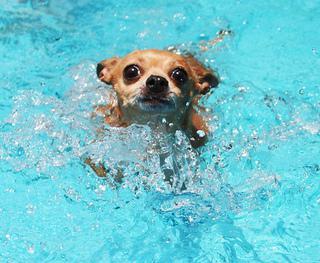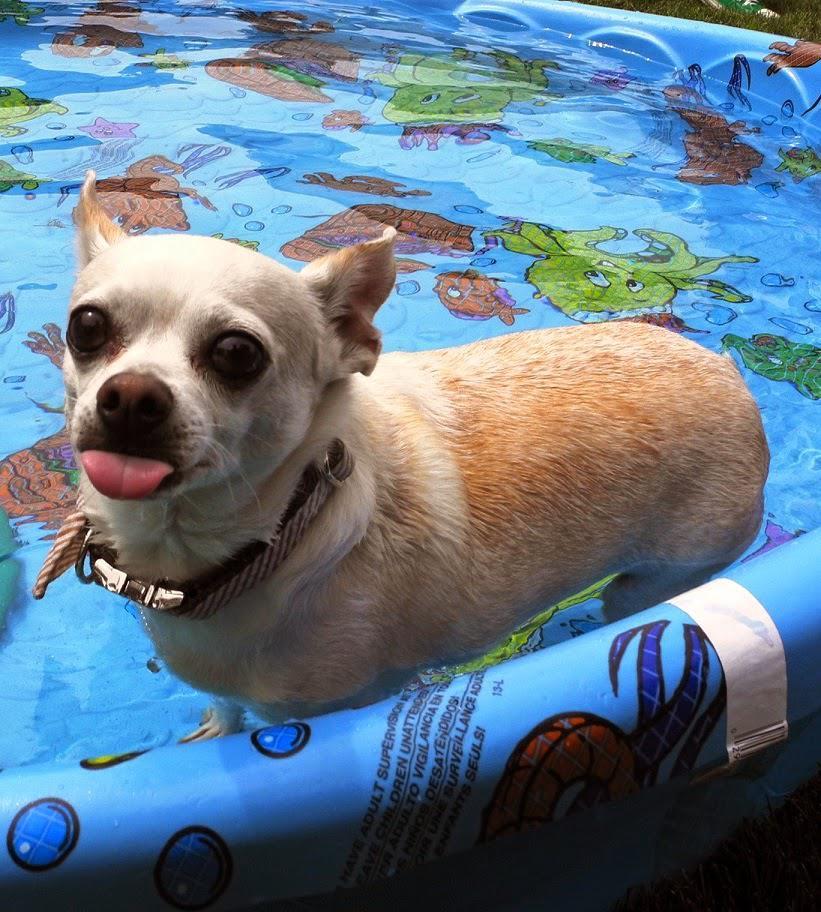The first image is the image on the left, the second image is the image on the right. Given the left and right images, does the statement "There are two dogs in the pictures." hold true? Answer yes or no. Yes. The first image is the image on the left, the second image is the image on the right. Analyze the images presented: Is the assertion "The dog in the pool is facing towards the camera, showing its big eyes." valid? Answer yes or no. Yes. 